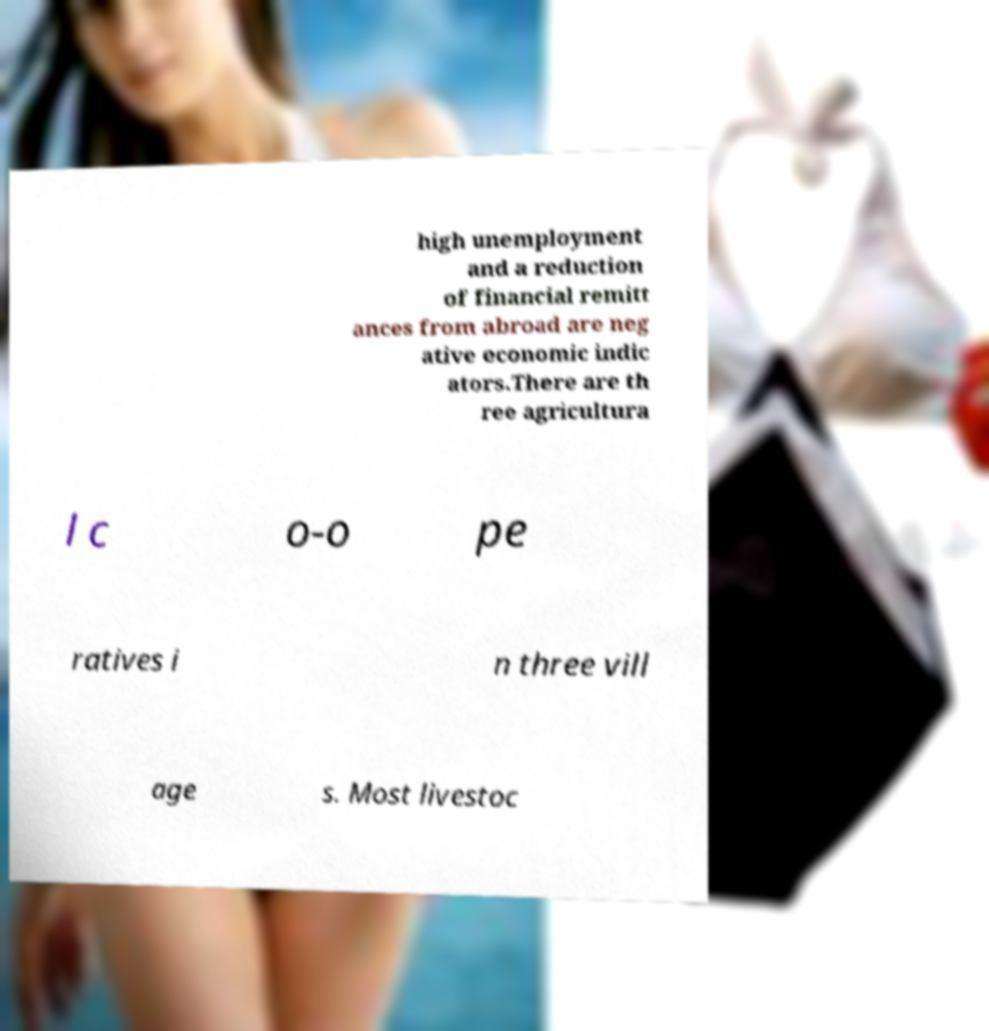Could you assist in decoding the text presented in this image and type it out clearly? high unemployment and a reduction of financial remitt ances from abroad are neg ative economic indic ators.There are th ree agricultura l c o-o pe ratives i n three vill age s. Most livestoc 